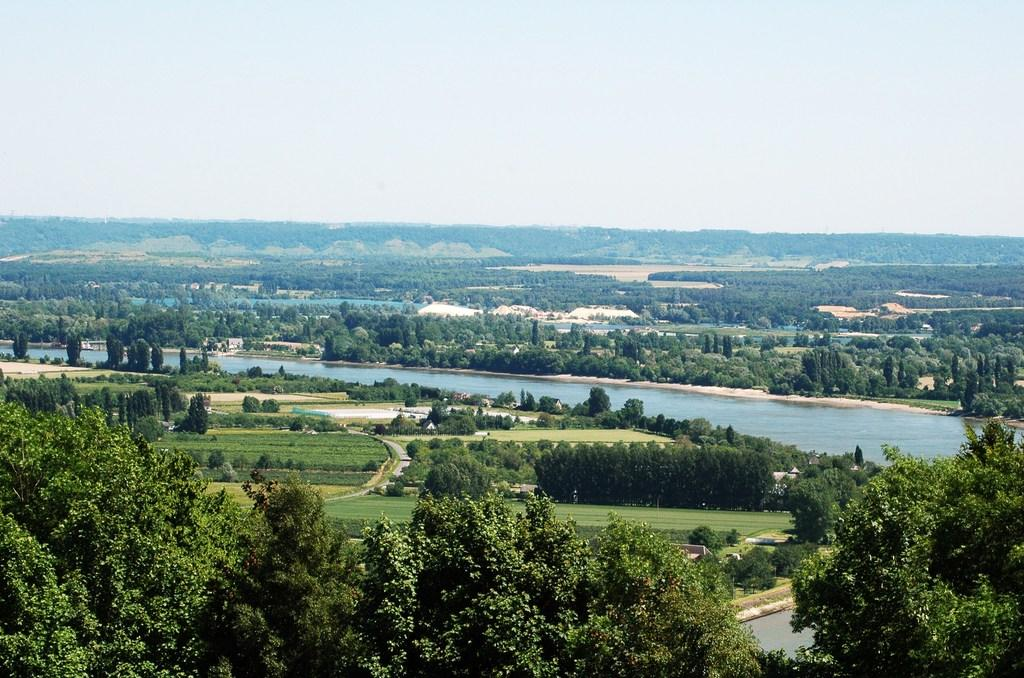What is the main feature in the center of the image? There are trees in the center of the image. What covers the ground in the image? There is grass on the ground. What can be seen in the background of the image? There are trees, water, and plants visible in the background. How many friends are participating in the competition in the image? There is no competition or friends present in the image; it features trees, grass, and background elements. 